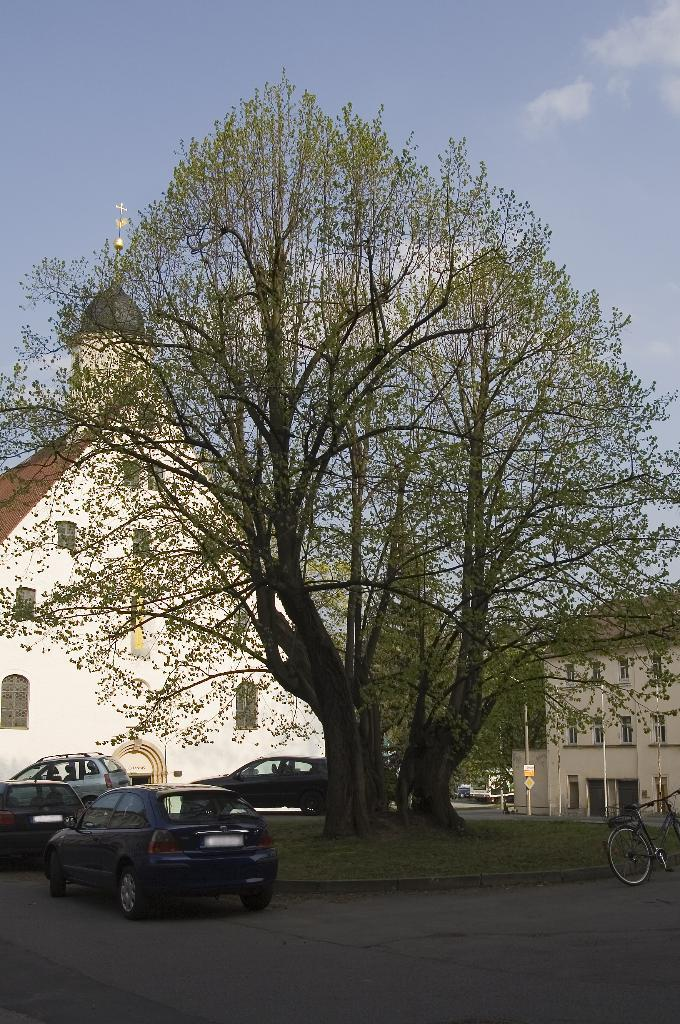What type of vehicles are on the road in the image? There are cars on the road in the image. What other mode of transportation can be seen on the road? There is a bicycle on the road in the image. What can be seen in the background of the image? There is a tree, houses, and the sky visible in the background of the image. Where is the monkey sitting in the image? There is no monkey present in the image. What does the mom say to the child in the image? There is no mom or child present in the image. 